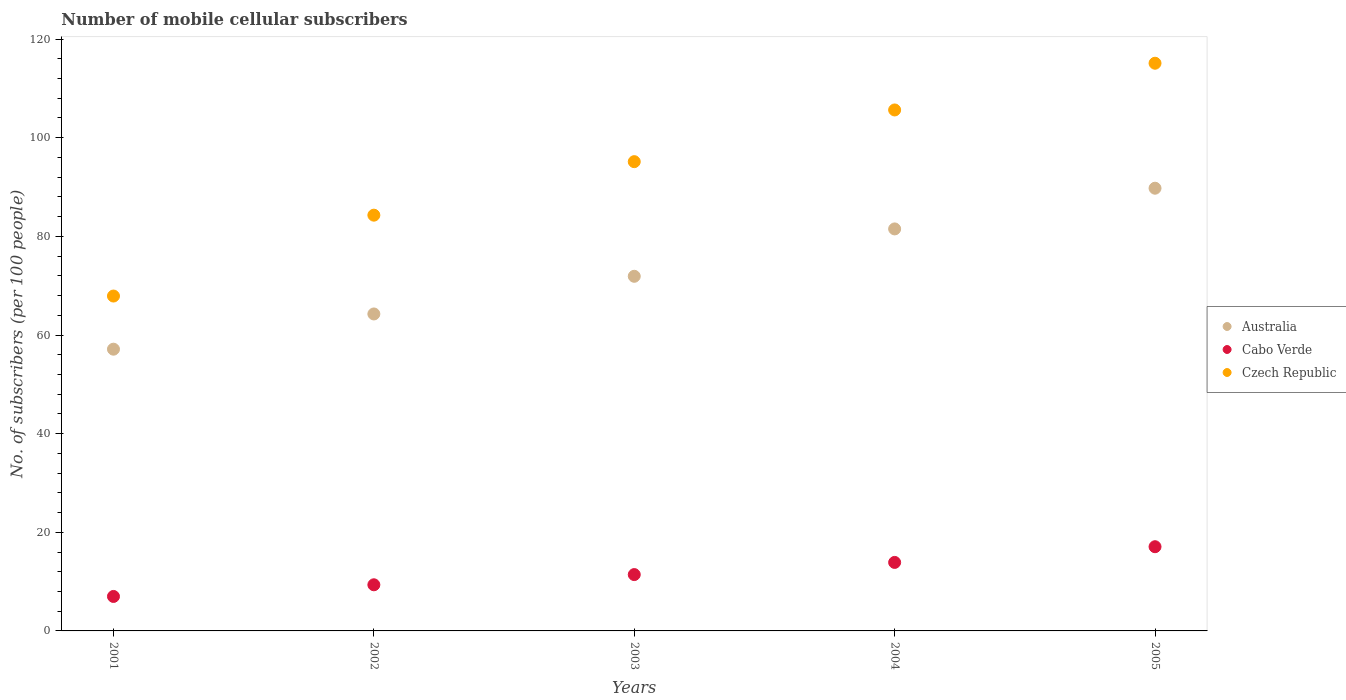How many different coloured dotlines are there?
Keep it short and to the point. 3. What is the number of mobile cellular subscribers in Australia in 2001?
Provide a short and direct response. 57.12. Across all years, what is the maximum number of mobile cellular subscribers in Cabo Verde?
Provide a succinct answer. 17.07. Across all years, what is the minimum number of mobile cellular subscribers in Cabo Verde?
Keep it short and to the point. 6.99. In which year was the number of mobile cellular subscribers in Cabo Verde minimum?
Your answer should be very brief. 2001. What is the total number of mobile cellular subscribers in Czech Republic in the graph?
Make the answer very short. 468.08. What is the difference between the number of mobile cellular subscribers in Cabo Verde in 2001 and that in 2002?
Provide a succinct answer. -2.37. What is the difference between the number of mobile cellular subscribers in Cabo Verde in 2004 and the number of mobile cellular subscribers in Australia in 2001?
Offer a very short reply. -43.23. What is the average number of mobile cellular subscribers in Cabo Verde per year?
Give a very brief answer. 11.75. In the year 2004, what is the difference between the number of mobile cellular subscribers in Czech Republic and number of mobile cellular subscribers in Australia?
Make the answer very short. 24.12. In how many years, is the number of mobile cellular subscribers in Australia greater than 20?
Give a very brief answer. 5. What is the ratio of the number of mobile cellular subscribers in Czech Republic in 2001 to that in 2002?
Give a very brief answer. 0.81. Is the number of mobile cellular subscribers in Czech Republic in 2001 less than that in 2003?
Offer a very short reply. Yes. Is the difference between the number of mobile cellular subscribers in Czech Republic in 2002 and 2004 greater than the difference between the number of mobile cellular subscribers in Australia in 2002 and 2004?
Provide a short and direct response. No. What is the difference between the highest and the second highest number of mobile cellular subscribers in Cabo Verde?
Offer a terse response. 3.18. What is the difference between the highest and the lowest number of mobile cellular subscribers in Australia?
Ensure brevity in your answer.  32.64. Is the sum of the number of mobile cellular subscribers in Cabo Verde in 2003 and 2004 greater than the maximum number of mobile cellular subscribers in Czech Republic across all years?
Your response must be concise. No. Is it the case that in every year, the sum of the number of mobile cellular subscribers in Australia and number of mobile cellular subscribers in Cabo Verde  is greater than the number of mobile cellular subscribers in Czech Republic?
Offer a terse response. No. How many dotlines are there?
Offer a very short reply. 3. What is the difference between two consecutive major ticks on the Y-axis?
Your answer should be very brief. 20. Does the graph contain any zero values?
Provide a short and direct response. No. Does the graph contain grids?
Provide a succinct answer. No. What is the title of the graph?
Provide a succinct answer. Number of mobile cellular subscribers. What is the label or title of the X-axis?
Provide a short and direct response. Years. What is the label or title of the Y-axis?
Offer a terse response. No. of subscribers (per 100 people). What is the No. of subscribers (per 100 people) in Australia in 2001?
Provide a succinct answer. 57.12. What is the No. of subscribers (per 100 people) of Cabo Verde in 2001?
Your answer should be compact. 6.99. What is the No. of subscribers (per 100 people) of Czech Republic in 2001?
Provide a short and direct response. 67.9. What is the No. of subscribers (per 100 people) in Australia in 2002?
Provide a succinct answer. 64.27. What is the No. of subscribers (per 100 people) of Cabo Verde in 2002?
Provide a succinct answer. 9.35. What is the No. of subscribers (per 100 people) of Czech Republic in 2002?
Keep it short and to the point. 84.3. What is the No. of subscribers (per 100 people) in Australia in 2003?
Offer a terse response. 71.9. What is the No. of subscribers (per 100 people) in Cabo Verde in 2003?
Offer a very short reply. 11.42. What is the No. of subscribers (per 100 people) of Czech Republic in 2003?
Ensure brevity in your answer.  95.15. What is the No. of subscribers (per 100 people) in Australia in 2004?
Provide a succinct answer. 81.51. What is the No. of subscribers (per 100 people) in Cabo Verde in 2004?
Provide a succinct answer. 13.89. What is the No. of subscribers (per 100 people) of Czech Republic in 2004?
Your answer should be compact. 105.63. What is the No. of subscribers (per 100 people) in Australia in 2005?
Provide a succinct answer. 89.76. What is the No. of subscribers (per 100 people) of Cabo Verde in 2005?
Make the answer very short. 17.07. What is the No. of subscribers (per 100 people) of Czech Republic in 2005?
Your answer should be compact. 115.1. Across all years, what is the maximum No. of subscribers (per 100 people) in Australia?
Your response must be concise. 89.76. Across all years, what is the maximum No. of subscribers (per 100 people) in Cabo Verde?
Keep it short and to the point. 17.07. Across all years, what is the maximum No. of subscribers (per 100 people) in Czech Republic?
Provide a succinct answer. 115.1. Across all years, what is the minimum No. of subscribers (per 100 people) in Australia?
Give a very brief answer. 57.12. Across all years, what is the minimum No. of subscribers (per 100 people) of Cabo Verde?
Keep it short and to the point. 6.99. Across all years, what is the minimum No. of subscribers (per 100 people) of Czech Republic?
Make the answer very short. 67.9. What is the total No. of subscribers (per 100 people) in Australia in the graph?
Your answer should be very brief. 364.57. What is the total No. of subscribers (per 100 people) in Cabo Verde in the graph?
Offer a very short reply. 58.73. What is the total No. of subscribers (per 100 people) in Czech Republic in the graph?
Provide a short and direct response. 468.08. What is the difference between the No. of subscribers (per 100 people) of Australia in 2001 and that in 2002?
Give a very brief answer. -7.14. What is the difference between the No. of subscribers (per 100 people) of Cabo Verde in 2001 and that in 2002?
Offer a terse response. -2.37. What is the difference between the No. of subscribers (per 100 people) in Czech Republic in 2001 and that in 2002?
Keep it short and to the point. -16.4. What is the difference between the No. of subscribers (per 100 people) of Australia in 2001 and that in 2003?
Your answer should be very brief. -14.78. What is the difference between the No. of subscribers (per 100 people) of Cabo Verde in 2001 and that in 2003?
Your answer should be compact. -4.43. What is the difference between the No. of subscribers (per 100 people) in Czech Republic in 2001 and that in 2003?
Provide a short and direct response. -27.25. What is the difference between the No. of subscribers (per 100 people) of Australia in 2001 and that in 2004?
Offer a terse response. -24.39. What is the difference between the No. of subscribers (per 100 people) of Cabo Verde in 2001 and that in 2004?
Ensure brevity in your answer.  -6.9. What is the difference between the No. of subscribers (per 100 people) in Czech Republic in 2001 and that in 2004?
Your answer should be very brief. -37.73. What is the difference between the No. of subscribers (per 100 people) in Australia in 2001 and that in 2005?
Give a very brief answer. -32.64. What is the difference between the No. of subscribers (per 100 people) of Cabo Verde in 2001 and that in 2005?
Offer a very short reply. -10.08. What is the difference between the No. of subscribers (per 100 people) of Czech Republic in 2001 and that in 2005?
Your response must be concise. -47.2. What is the difference between the No. of subscribers (per 100 people) of Australia in 2002 and that in 2003?
Your answer should be very brief. -7.64. What is the difference between the No. of subscribers (per 100 people) in Cabo Verde in 2002 and that in 2003?
Your answer should be compact. -2.07. What is the difference between the No. of subscribers (per 100 people) in Czech Republic in 2002 and that in 2003?
Ensure brevity in your answer.  -10.85. What is the difference between the No. of subscribers (per 100 people) in Australia in 2002 and that in 2004?
Give a very brief answer. -17.24. What is the difference between the No. of subscribers (per 100 people) of Cabo Verde in 2002 and that in 2004?
Keep it short and to the point. -4.54. What is the difference between the No. of subscribers (per 100 people) in Czech Republic in 2002 and that in 2004?
Keep it short and to the point. -21.33. What is the difference between the No. of subscribers (per 100 people) in Australia in 2002 and that in 2005?
Provide a short and direct response. -25.5. What is the difference between the No. of subscribers (per 100 people) of Cabo Verde in 2002 and that in 2005?
Your response must be concise. -7.72. What is the difference between the No. of subscribers (per 100 people) of Czech Republic in 2002 and that in 2005?
Give a very brief answer. -30.81. What is the difference between the No. of subscribers (per 100 people) in Australia in 2003 and that in 2004?
Your answer should be compact. -9.61. What is the difference between the No. of subscribers (per 100 people) of Cabo Verde in 2003 and that in 2004?
Make the answer very short. -2.47. What is the difference between the No. of subscribers (per 100 people) of Czech Republic in 2003 and that in 2004?
Your response must be concise. -10.48. What is the difference between the No. of subscribers (per 100 people) of Australia in 2003 and that in 2005?
Your answer should be very brief. -17.86. What is the difference between the No. of subscribers (per 100 people) of Cabo Verde in 2003 and that in 2005?
Make the answer very short. -5.65. What is the difference between the No. of subscribers (per 100 people) in Czech Republic in 2003 and that in 2005?
Make the answer very short. -19.96. What is the difference between the No. of subscribers (per 100 people) of Australia in 2004 and that in 2005?
Your answer should be compact. -8.25. What is the difference between the No. of subscribers (per 100 people) of Cabo Verde in 2004 and that in 2005?
Ensure brevity in your answer.  -3.18. What is the difference between the No. of subscribers (per 100 people) in Czech Republic in 2004 and that in 2005?
Ensure brevity in your answer.  -9.47. What is the difference between the No. of subscribers (per 100 people) of Australia in 2001 and the No. of subscribers (per 100 people) of Cabo Verde in 2002?
Your answer should be very brief. 47.77. What is the difference between the No. of subscribers (per 100 people) of Australia in 2001 and the No. of subscribers (per 100 people) of Czech Republic in 2002?
Give a very brief answer. -27.17. What is the difference between the No. of subscribers (per 100 people) of Cabo Verde in 2001 and the No. of subscribers (per 100 people) of Czech Republic in 2002?
Your response must be concise. -77.31. What is the difference between the No. of subscribers (per 100 people) in Australia in 2001 and the No. of subscribers (per 100 people) in Cabo Verde in 2003?
Give a very brief answer. 45.7. What is the difference between the No. of subscribers (per 100 people) of Australia in 2001 and the No. of subscribers (per 100 people) of Czech Republic in 2003?
Your response must be concise. -38.02. What is the difference between the No. of subscribers (per 100 people) of Cabo Verde in 2001 and the No. of subscribers (per 100 people) of Czech Republic in 2003?
Your answer should be very brief. -88.16. What is the difference between the No. of subscribers (per 100 people) of Australia in 2001 and the No. of subscribers (per 100 people) of Cabo Verde in 2004?
Ensure brevity in your answer.  43.23. What is the difference between the No. of subscribers (per 100 people) of Australia in 2001 and the No. of subscribers (per 100 people) of Czech Republic in 2004?
Keep it short and to the point. -48.51. What is the difference between the No. of subscribers (per 100 people) of Cabo Verde in 2001 and the No. of subscribers (per 100 people) of Czech Republic in 2004?
Your answer should be very brief. -98.64. What is the difference between the No. of subscribers (per 100 people) in Australia in 2001 and the No. of subscribers (per 100 people) in Cabo Verde in 2005?
Provide a succinct answer. 40.05. What is the difference between the No. of subscribers (per 100 people) in Australia in 2001 and the No. of subscribers (per 100 people) in Czech Republic in 2005?
Your answer should be very brief. -57.98. What is the difference between the No. of subscribers (per 100 people) of Cabo Verde in 2001 and the No. of subscribers (per 100 people) of Czech Republic in 2005?
Offer a terse response. -108.11. What is the difference between the No. of subscribers (per 100 people) in Australia in 2002 and the No. of subscribers (per 100 people) in Cabo Verde in 2003?
Offer a very short reply. 52.84. What is the difference between the No. of subscribers (per 100 people) of Australia in 2002 and the No. of subscribers (per 100 people) of Czech Republic in 2003?
Your response must be concise. -30.88. What is the difference between the No. of subscribers (per 100 people) of Cabo Verde in 2002 and the No. of subscribers (per 100 people) of Czech Republic in 2003?
Your answer should be compact. -85.79. What is the difference between the No. of subscribers (per 100 people) of Australia in 2002 and the No. of subscribers (per 100 people) of Cabo Verde in 2004?
Offer a very short reply. 50.38. What is the difference between the No. of subscribers (per 100 people) of Australia in 2002 and the No. of subscribers (per 100 people) of Czech Republic in 2004?
Offer a terse response. -41.36. What is the difference between the No. of subscribers (per 100 people) in Cabo Verde in 2002 and the No. of subscribers (per 100 people) in Czech Republic in 2004?
Offer a terse response. -96.28. What is the difference between the No. of subscribers (per 100 people) of Australia in 2002 and the No. of subscribers (per 100 people) of Cabo Verde in 2005?
Offer a very short reply. 47.19. What is the difference between the No. of subscribers (per 100 people) of Australia in 2002 and the No. of subscribers (per 100 people) of Czech Republic in 2005?
Your response must be concise. -50.84. What is the difference between the No. of subscribers (per 100 people) in Cabo Verde in 2002 and the No. of subscribers (per 100 people) in Czech Republic in 2005?
Keep it short and to the point. -105.75. What is the difference between the No. of subscribers (per 100 people) in Australia in 2003 and the No. of subscribers (per 100 people) in Cabo Verde in 2004?
Offer a very short reply. 58.01. What is the difference between the No. of subscribers (per 100 people) in Australia in 2003 and the No. of subscribers (per 100 people) in Czech Republic in 2004?
Provide a succinct answer. -33.73. What is the difference between the No. of subscribers (per 100 people) of Cabo Verde in 2003 and the No. of subscribers (per 100 people) of Czech Republic in 2004?
Ensure brevity in your answer.  -94.21. What is the difference between the No. of subscribers (per 100 people) of Australia in 2003 and the No. of subscribers (per 100 people) of Cabo Verde in 2005?
Provide a succinct answer. 54.83. What is the difference between the No. of subscribers (per 100 people) in Australia in 2003 and the No. of subscribers (per 100 people) in Czech Republic in 2005?
Your answer should be compact. -43.2. What is the difference between the No. of subscribers (per 100 people) in Cabo Verde in 2003 and the No. of subscribers (per 100 people) in Czech Republic in 2005?
Keep it short and to the point. -103.68. What is the difference between the No. of subscribers (per 100 people) in Australia in 2004 and the No. of subscribers (per 100 people) in Cabo Verde in 2005?
Provide a succinct answer. 64.44. What is the difference between the No. of subscribers (per 100 people) in Australia in 2004 and the No. of subscribers (per 100 people) in Czech Republic in 2005?
Make the answer very short. -33.59. What is the difference between the No. of subscribers (per 100 people) of Cabo Verde in 2004 and the No. of subscribers (per 100 people) of Czech Republic in 2005?
Your answer should be compact. -101.21. What is the average No. of subscribers (per 100 people) of Australia per year?
Your answer should be compact. 72.91. What is the average No. of subscribers (per 100 people) of Cabo Verde per year?
Your answer should be compact. 11.75. What is the average No. of subscribers (per 100 people) in Czech Republic per year?
Ensure brevity in your answer.  93.62. In the year 2001, what is the difference between the No. of subscribers (per 100 people) of Australia and No. of subscribers (per 100 people) of Cabo Verde?
Keep it short and to the point. 50.14. In the year 2001, what is the difference between the No. of subscribers (per 100 people) of Australia and No. of subscribers (per 100 people) of Czech Republic?
Make the answer very short. -10.78. In the year 2001, what is the difference between the No. of subscribers (per 100 people) in Cabo Verde and No. of subscribers (per 100 people) in Czech Republic?
Ensure brevity in your answer.  -60.91. In the year 2002, what is the difference between the No. of subscribers (per 100 people) of Australia and No. of subscribers (per 100 people) of Cabo Verde?
Provide a succinct answer. 54.91. In the year 2002, what is the difference between the No. of subscribers (per 100 people) in Australia and No. of subscribers (per 100 people) in Czech Republic?
Keep it short and to the point. -20.03. In the year 2002, what is the difference between the No. of subscribers (per 100 people) in Cabo Verde and No. of subscribers (per 100 people) in Czech Republic?
Keep it short and to the point. -74.94. In the year 2003, what is the difference between the No. of subscribers (per 100 people) in Australia and No. of subscribers (per 100 people) in Cabo Verde?
Your response must be concise. 60.48. In the year 2003, what is the difference between the No. of subscribers (per 100 people) of Australia and No. of subscribers (per 100 people) of Czech Republic?
Provide a short and direct response. -23.24. In the year 2003, what is the difference between the No. of subscribers (per 100 people) in Cabo Verde and No. of subscribers (per 100 people) in Czech Republic?
Offer a terse response. -83.72. In the year 2004, what is the difference between the No. of subscribers (per 100 people) in Australia and No. of subscribers (per 100 people) in Cabo Verde?
Your response must be concise. 67.62. In the year 2004, what is the difference between the No. of subscribers (per 100 people) in Australia and No. of subscribers (per 100 people) in Czech Republic?
Give a very brief answer. -24.12. In the year 2004, what is the difference between the No. of subscribers (per 100 people) of Cabo Verde and No. of subscribers (per 100 people) of Czech Republic?
Provide a succinct answer. -91.74. In the year 2005, what is the difference between the No. of subscribers (per 100 people) in Australia and No. of subscribers (per 100 people) in Cabo Verde?
Your answer should be very brief. 72.69. In the year 2005, what is the difference between the No. of subscribers (per 100 people) in Australia and No. of subscribers (per 100 people) in Czech Republic?
Make the answer very short. -25.34. In the year 2005, what is the difference between the No. of subscribers (per 100 people) in Cabo Verde and No. of subscribers (per 100 people) in Czech Republic?
Your response must be concise. -98.03. What is the ratio of the No. of subscribers (per 100 people) of Cabo Verde in 2001 to that in 2002?
Keep it short and to the point. 0.75. What is the ratio of the No. of subscribers (per 100 people) of Czech Republic in 2001 to that in 2002?
Offer a very short reply. 0.81. What is the ratio of the No. of subscribers (per 100 people) of Australia in 2001 to that in 2003?
Your response must be concise. 0.79. What is the ratio of the No. of subscribers (per 100 people) in Cabo Verde in 2001 to that in 2003?
Keep it short and to the point. 0.61. What is the ratio of the No. of subscribers (per 100 people) in Czech Republic in 2001 to that in 2003?
Your answer should be compact. 0.71. What is the ratio of the No. of subscribers (per 100 people) of Australia in 2001 to that in 2004?
Your response must be concise. 0.7. What is the ratio of the No. of subscribers (per 100 people) in Cabo Verde in 2001 to that in 2004?
Offer a very short reply. 0.5. What is the ratio of the No. of subscribers (per 100 people) of Czech Republic in 2001 to that in 2004?
Ensure brevity in your answer.  0.64. What is the ratio of the No. of subscribers (per 100 people) in Australia in 2001 to that in 2005?
Keep it short and to the point. 0.64. What is the ratio of the No. of subscribers (per 100 people) in Cabo Verde in 2001 to that in 2005?
Your answer should be very brief. 0.41. What is the ratio of the No. of subscribers (per 100 people) of Czech Republic in 2001 to that in 2005?
Keep it short and to the point. 0.59. What is the ratio of the No. of subscribers (per 100 people) in Australia in 2002 to that in 2003?
Make the answer very short. 0.89. What is the ratio of the No. of subscribers (per 100 people) of Cabo Verde in 2002 to that in 2003?
Provide a succinct answer. 0.82. What is the ratio of the No. of subscribers (per 100 people) of Czech Republic in 2002 to that in 2003?
Offer a terse response. 0.89. What is the ratio of the No. of subscribers (per 100 people) in Australia in 2002 to that in 2004?
Make the answer very short. 0.79. What is the ratio of the No. of subscribers (per 100 people) of Cabo Verde in 2002 to that in 2004?
Offer a terse response. 0.67. What is the ratio of the No. of subscribers (per 100 people) in Czech Republic in 2002 to that in 2004?
Make the answer very short. 0.8. What is the ratio of the No. of subscribers (per 100 people) of Australia in 2002 to that in 2005?
Your answer should be compact. 0.72. What is the ratio of the No. of subscribers (per 100 people) of Cabo Verde in 2002 to that in 2005?
Make the answer very short. 0.55. What is the ratio of the No. of subscribers (per 100 people) in Czech Republic in 2002 to that in 2005?
Your answer should be compact. 0.73. What is the ratio of the No. of subscribers (per 100 people) of Australia in 2003 to that in 2004?
Keep it short and to the point. 0.88. What is the ratio of the No. of subscribers (per 100 people) of Cabo Verde in 2003 to that in 2004?
Keep it short and to the point. 0.82. What is the ratio of the No. of subscribers (per 100 people) in Czech Republic in 2003 to that in 2004?
Offer a very short reply. 0.9. What is the ratio of the No. of subscribers (per 100 people) in Australia in 2003 to that in 2005?
Offer a very short reply. 0.8. What is the ratio of the No. of subscribers (per 100 people) in Cabo Verde in 2003 to that in 2005?
Your answer should be very brief. 0.67. What is the ratio of the No. of subscribers (per 100 people) in Czech Republic in 2003 to that in 2005?
Offer a terse response. 0.83. What is the ratio of the No. of subscribers (per 100 people) in Australia in 2004 to that in 2005?
Provide a succinct answer. 0.91. What is the ratio of the No. of subscribers (per 100 people) in Cabo Verde in 2004 to that in 2005?
Give a very brief answer. 0.81. What is the ratio of the No. of subscribers (per 100 people) of Czech Republic in 2004 to that in 2005?
Give a very brief answer. 0.92. What is the difference between the highest and the second highest No. of subscribers (per 100 people) of Australia?
Provide a short and direct response. 8.25. What is the difference between the highest and the second highest No. of subscribers (per 100 people) in Cabo Verde?
Your response must be concise. 3.18. What is the difference between the highest and the second highest No. of subscribers (per 100 people) in Czech Republic?
Offer a terse response. 9.47. What is the difference between the highest and the lowest No. of subscribers (per 100 people) of Australia?
Ensure brevity in your answer.  32.64. What is the difference between the highest and the lowest No. of subscribers (per 100 people) in Cabo Verde?
Your answer should be very brief. 10.08. What is the difference between the highest and the lowest No. of subscribers (per 100 people) in Czech Republic?
Your answer should be very brief. 47.2. 